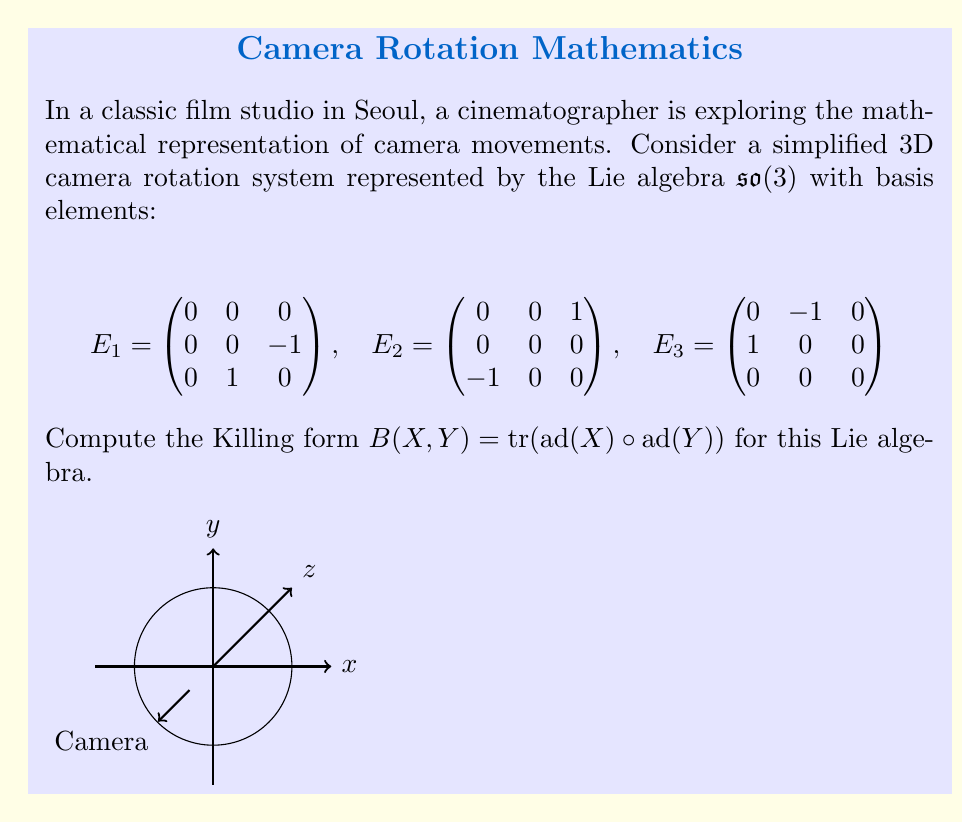Provide a solution to this math problem. Let's approach this step-by-step:

1) First, we need to calculate the adjoint representations ad($E_i$) for each basis element:

   ad($E_1$)($E_j$) = [$E_1$, $E_j$]
   ad($E_2$)($E_j$) = [$E_2$, $E_j$]
   ad($E_3$)($E_j$) = [$E_3$, $E_j$]

2) Let's compute these commutators:

   [$E_1$, $E_2$] = $E_3$
   [$E_2$, $E_3$] = $E_1$
   [$E_3$, $E_1$] = $E_2$

3) From these, we can write the matrices of the adjoint representations:

   ad($E_1$) = $\begin{pmatrix}
   0 & 0 & 0 \\
   0 & 0 & -1 \\
   0 & 1 & 0
   \end{pmatrix}$

   ad($E_2$) = $\begin{pmatrix}
   0 & 0 & 1 \\
   0 & 0 & 0 \\
   -1 & 0 & 0
   \end{pmatrix}$

   ad($E_3$) = $\begin{pmatrix}
   0 & -1 & 0 \\
   1 & 0 & 0 \\
   0 & 0 & 0
   \end{pmatrix}$

4) Now, to compute the Killing form, we need to calculate:

   $B(E_i, E_j) = \text{tr}(\text{ad}(E_i) \circ \text{ad}(E_j))$

5) Let's calculate these:

   $B(E_1, E_1) = \text{tr}(\text{ad}(E_1) \circ \text{ad}(E_1)) = -2$
   $B(E_2, E_2) = \text{tr}(\text{ad}(E_2) \circ \text{ad}(E_2)) = -2$
   $B(E_3, E_3) = \text{tr}(\text{ad}(E_3) \circ \text{ad}(E_3)) = -2$

   $B(E_1, E_2) = B(E_2, E_1) = \text{tr}(\text{ad}(E_1) \circ \text{ad}(E_2)) = 0$
   $B(E_1, E_3) = B(E_3, E_1) = \text{tr}(\text{ad}(E_1) \circ \text{ad}(E_3)) = 0$
   $B(E_2, E_3) = B(E_3, E_2) = \text{tr}(\text{ad}(E_2) \circ \text{ad}(E_3)) = 0$

6) Therefore, the Killing form can be represented as a matrix:

   $B = \begin{pmatrix}
   -2 & 0 & 0 \\
   0 & -2 & 0 \\
   0 & 0 & -2
   \end{pmatrix}$
Answer: $B = -2I_3$, where $I_3$ is the 3x3 identity matrix. 